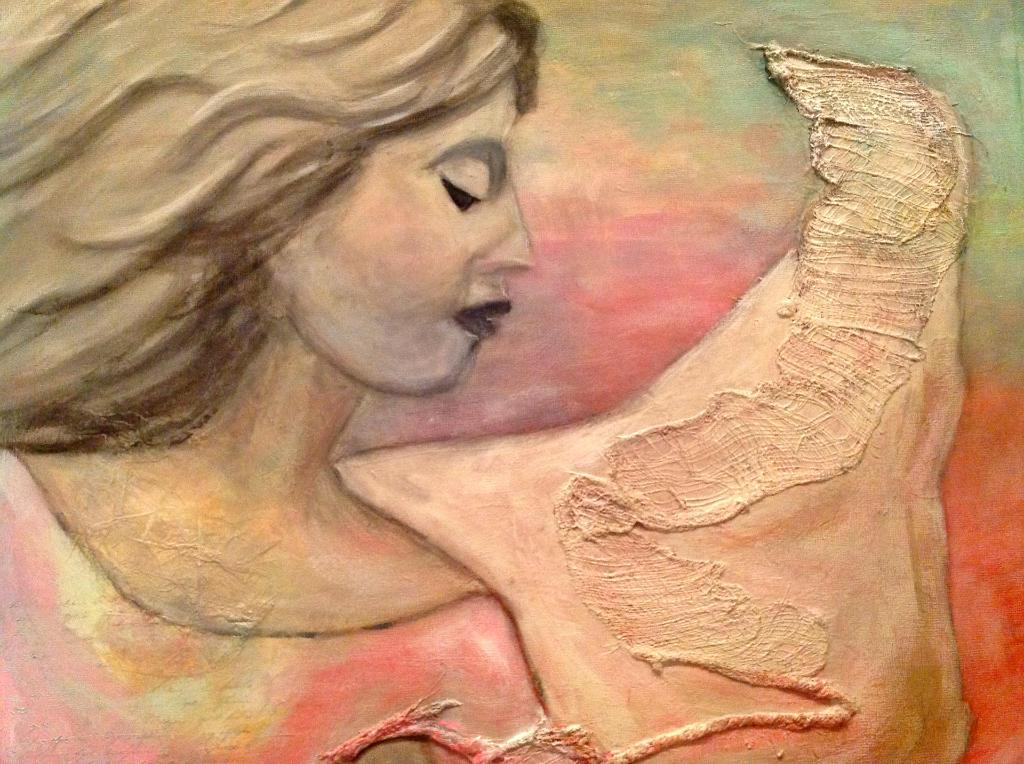What is depicted in the image? There is a painting of a woman in the image. What is the painting placed on? The painting is on an object. What type of glass is used to create the painting in the image? There is no mention of glass being used in the creation of the painting in the image. 